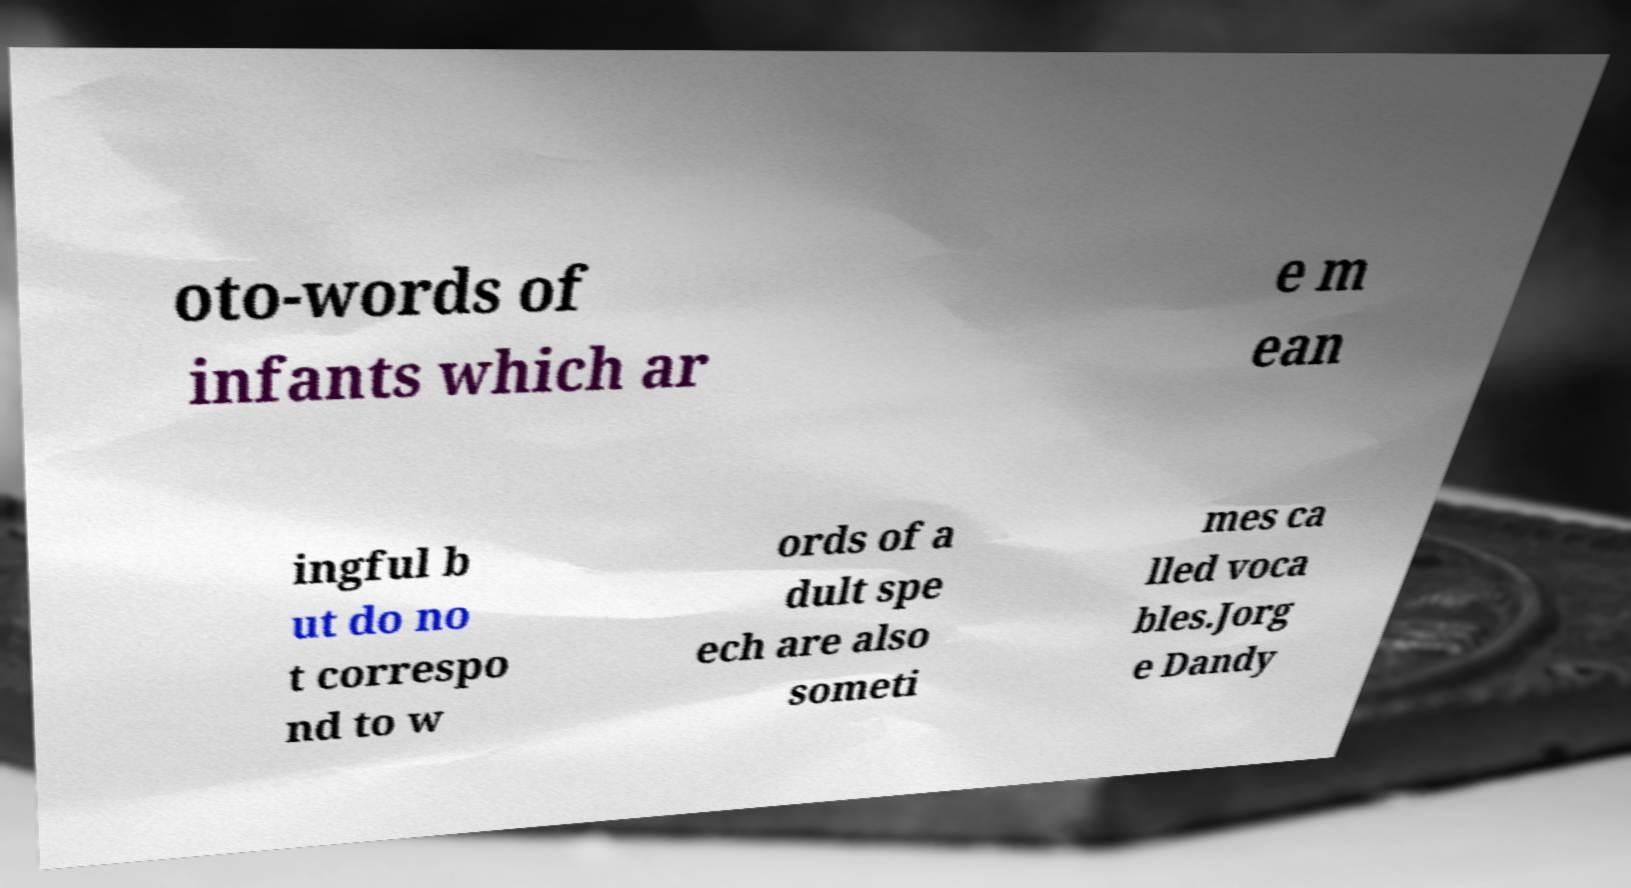Please read and relay the text visible in this image. What does it say? oto-words of infants which ar e m ean ingful b ut do no t correspo nd to w ords of a dult spe ech are also someti mes ca lled voca bles.Jorg e Dandy 